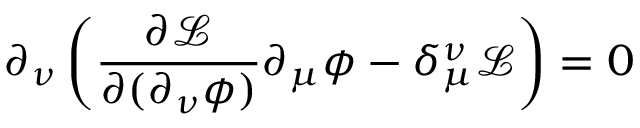Convert formula to latex. <formula><loc_0><loc_0><loc_500><loc_500>\partial _ { \nu } \left ( { \frac { \partial { \mathcal { L } } } { \partial ( \partial _ { \nu } \phi ) } } \partial _ { \mu } \phi - \delta _ { \mu } ^ { \nu } { \mathcal { L } } \right ) = 0</formula> 